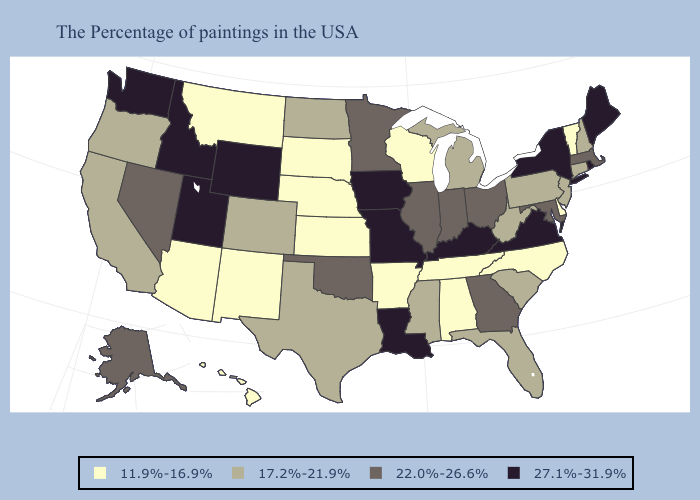Does New Mexico have the lowest value in the West?
Be succinct. Yes. Does New Jersey have a lower value than Oregon?
Write a very short answer. No. Does Connecticut have the lowest value in the Northeast?
Write a very short answer. No. Does Illinois have the highest value in the MidWest?
Write a very short answer. No. Name the states that have a value in the range 22.0%-26.6%?
Give a very brief answer. Massachusetts, Maryland, Ohio, Georgia, Indiana, Illinois, Minnesota, Oklahoma, Nevada, Alaska. Does Kentucky have the highest value in the South?
Concise answer only. Yes. How many symbols are there in the legend?
Keep it brief. 4. What is the highest value in the USA?
Keep it brief. 27.1%-31.9%. Does Vermont have the lowest value in the Northeast?
Short answer required. Yes. Name the states that have a value in the range 22.0%-26.6%?
Concise answer only. Massachusetts, Maryland, Ohio, Georgia, Indiana, Illinois, Minnesota, Oklahoma, Nevada, Alaska. Which states have the highest value in the USA?
Quick response, please. Maine, Rhode Island, New York, Virginia, Kentucky, Louisiana, Missouri, Iowa, Wyoming, Utah, Idaho, Washington. What is the lowest value in states that border South Carolina?
Answer briefly. 11.9%-16.9%. What is the lowest value in the USA?
Short answer required. 11.9%-16.9%. Name the states that have a value in the range 17.2%-21.9%?
Concise answer only. New Hampshire, Connecticut, New Jersey, Pennsylvania, South Carolina, West Virginia, Florida, Michigan, Mississippi, Texas, North Dakota, Colorado, California, Oregon. What is the value of North Dakota?
Answer briefly. 17.2%-21.9%. 